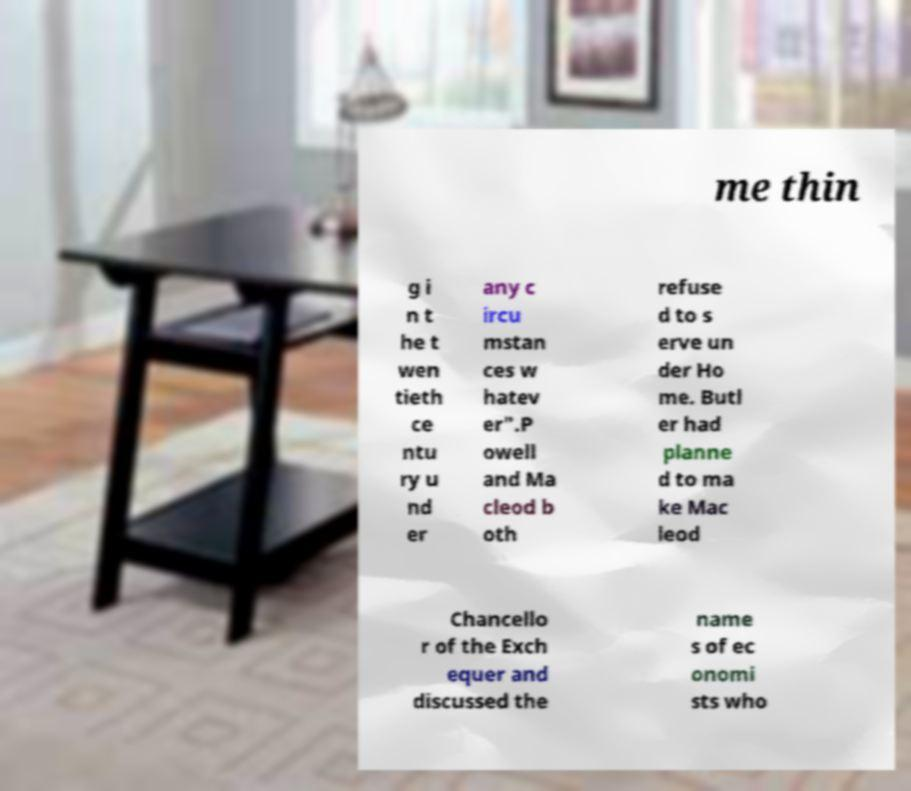Can you accurately transcribe the text from the provided image for me? me thin g i n t he t wen tieth ce ntu ry u nd er any c ircu mstan ces w hatev er".P owell and Ma cleod b oth refuse d to s erve un der Ho me. Butl er had planne d to ma ke Mac leod Chancello r of the Exch equer and discussed the name s of ec onomi sts who 